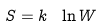<formula> <loc_0><loc_0><loc_500><loc_500>S = k \ \ln W</formula> 